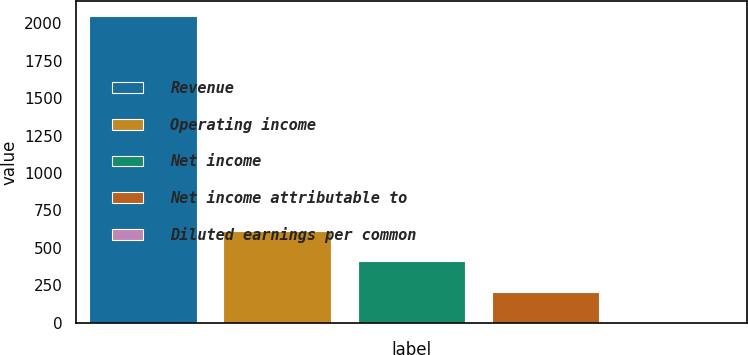Convert chart to OTSL. <chart><loc_0><loc_0><loc_500><loc_500><bar_chart><fcel>Revenue<fcel>Operating income<fcel>Net income<fcel>Net income attributable to<fcel>Diluted earnings per common<nl><fcel>2046.9<fcel>614.37<fcel>409.72<fcel>205.07<fcel>0.42<nl></chart> 